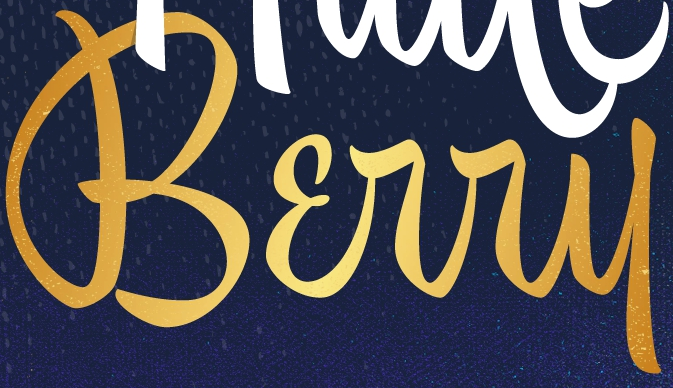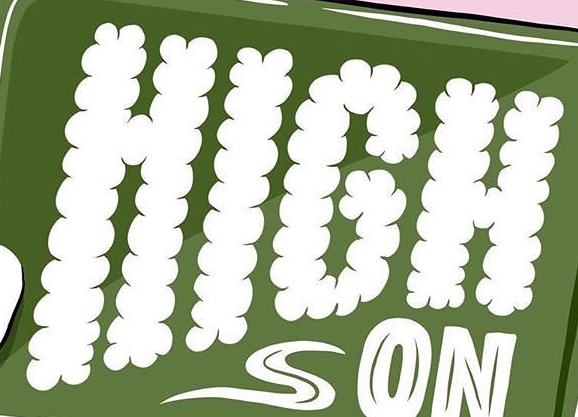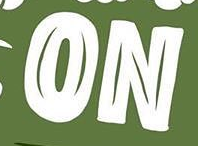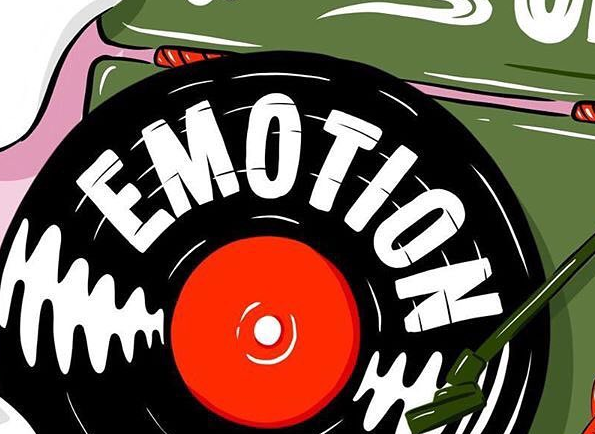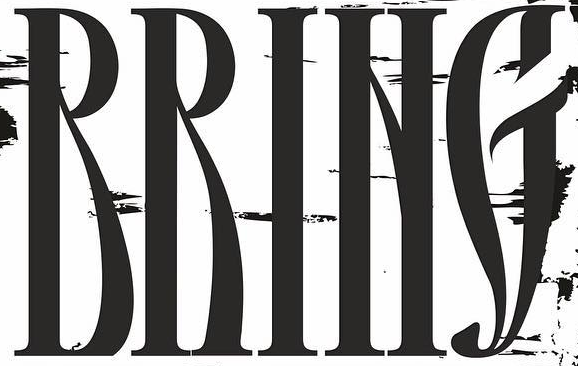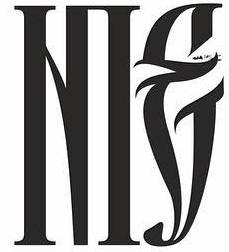What words can you see in these images in sequence, separated by a semicolon? Bɛrry; HIGH; ON; EMOTION; RRING; NIE 